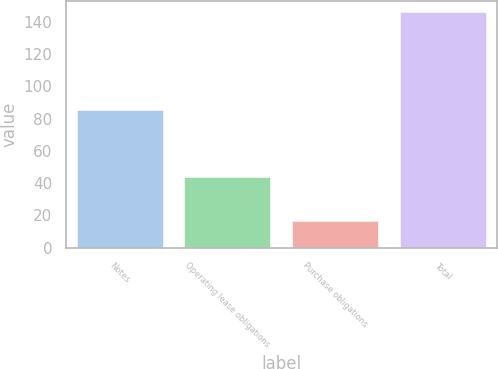Convert chart to OTSL. <chart><loc_0><loc_0><loc_500><loc_500><bar_chart><fcel>Notes<fcel>Operating lease obligations<fcel>Purchase obligations<fcel>Total<nl><fcel>85.5<fcel>43.7<fcel>16.7<fcel>145.9<nl></chart> 